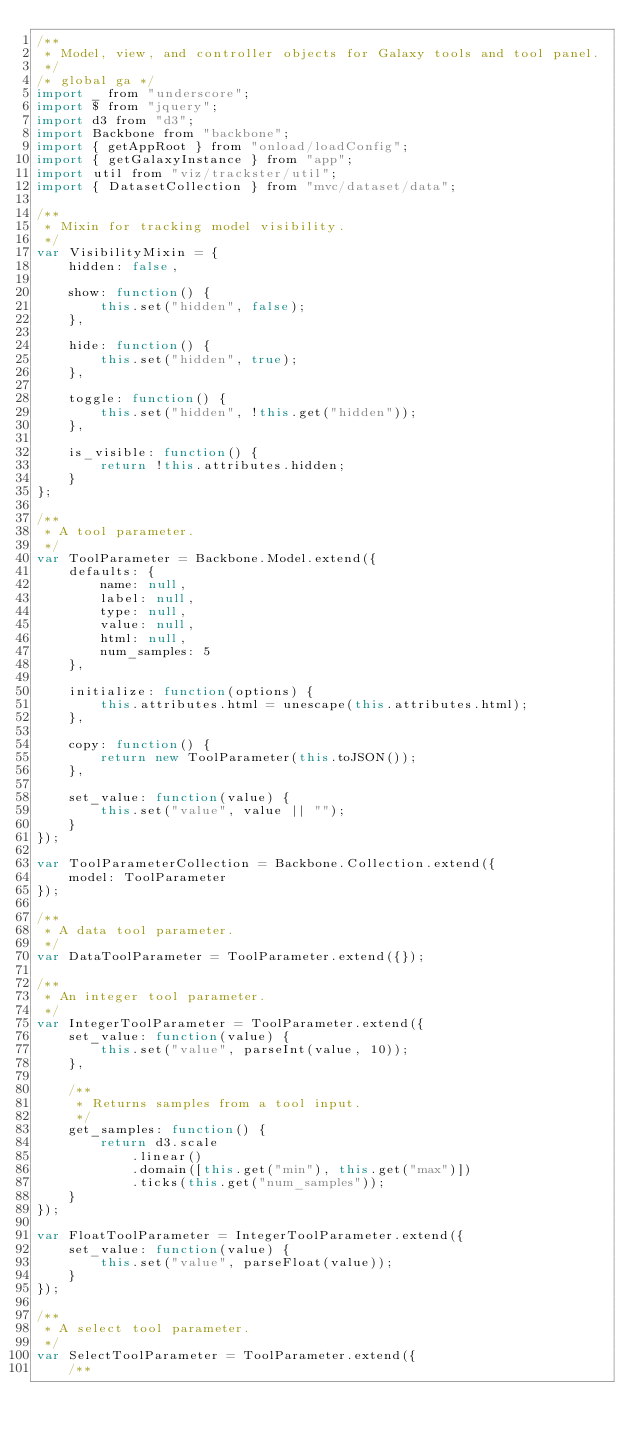Convert code to text. <code><loc_0><loc_0><loc_500><loc_500><_JavaScript_>/**
 * Model, view, and controller objects for Galaxy tools and tool panel.
 */
/* global ga */
import _ from "underscore";
import $ from "jquery";
import d3 from "d3";
import Backbone from "backbone";
import { getAppRoot } from "onload/loadConfig";
import { getGalaxyInstance } from "app";
import util from "viz/trackster/util";
import { DatasetCollection } from "mvc/dataset/data";

/**
 * Mixin for tracking model visibility.
 */
var VisibilityMixin = {
    hidden: false,

    show: function() {
        this.set("hidden", false);
    },

    hide: function() {
        this.set("hidden", true);
    },

    toggle: function() {
        this.set("hidden", !this.get("hidden"));
    },

    is_visible: function() {
        return !this.attributes.hidden;
    }
};

/**
 * A tool parameter.
 */
var ToolParameter = Backbone.Model.extend({
    defaults: {
        name: null,
        label: null,
        type: null,
        value: null,
        html: null,
        num_samples: 5
    },

    initialize: function(options) {
        this.attributes.html = unescape(this.attributes.html);
    },

    copy: function() {
        return new ToolParameter(this.toJSON());
    },

    set_value: function(value) {
        this.set("value", value || "");
    }
});

var ToolParameterCollection = Backbone.Collection.extend({
    model: ToolParameter
});

/**
 * A data tool parameter.
 */
var DataToolParameter = ToolParameter.extend({});

/**
 * An integer tool parameter.
 */
var IntegerToolParameter = ToolParameter.extend({
    set_value: function(value) {
        this.set("value", parseInt(value, 10));
    },

    /**
     * Returns samples from a tool input.
     */
    get_samples: function() {
        return d3.scale
            .linear()
            .domain([this.get("min"), this.get("max")])
            .ticks(this.get("num_samples"));
    }
});

var FloatToolParameter = IntegerToolParameter.extend({
    set_value: function(value) {
        this.set("value", parseFloat(value));
    }
});

/**
 * A select tool parameter.
 */
var SelectToolParameter = ToolParameter.extend({
    /**</code> 